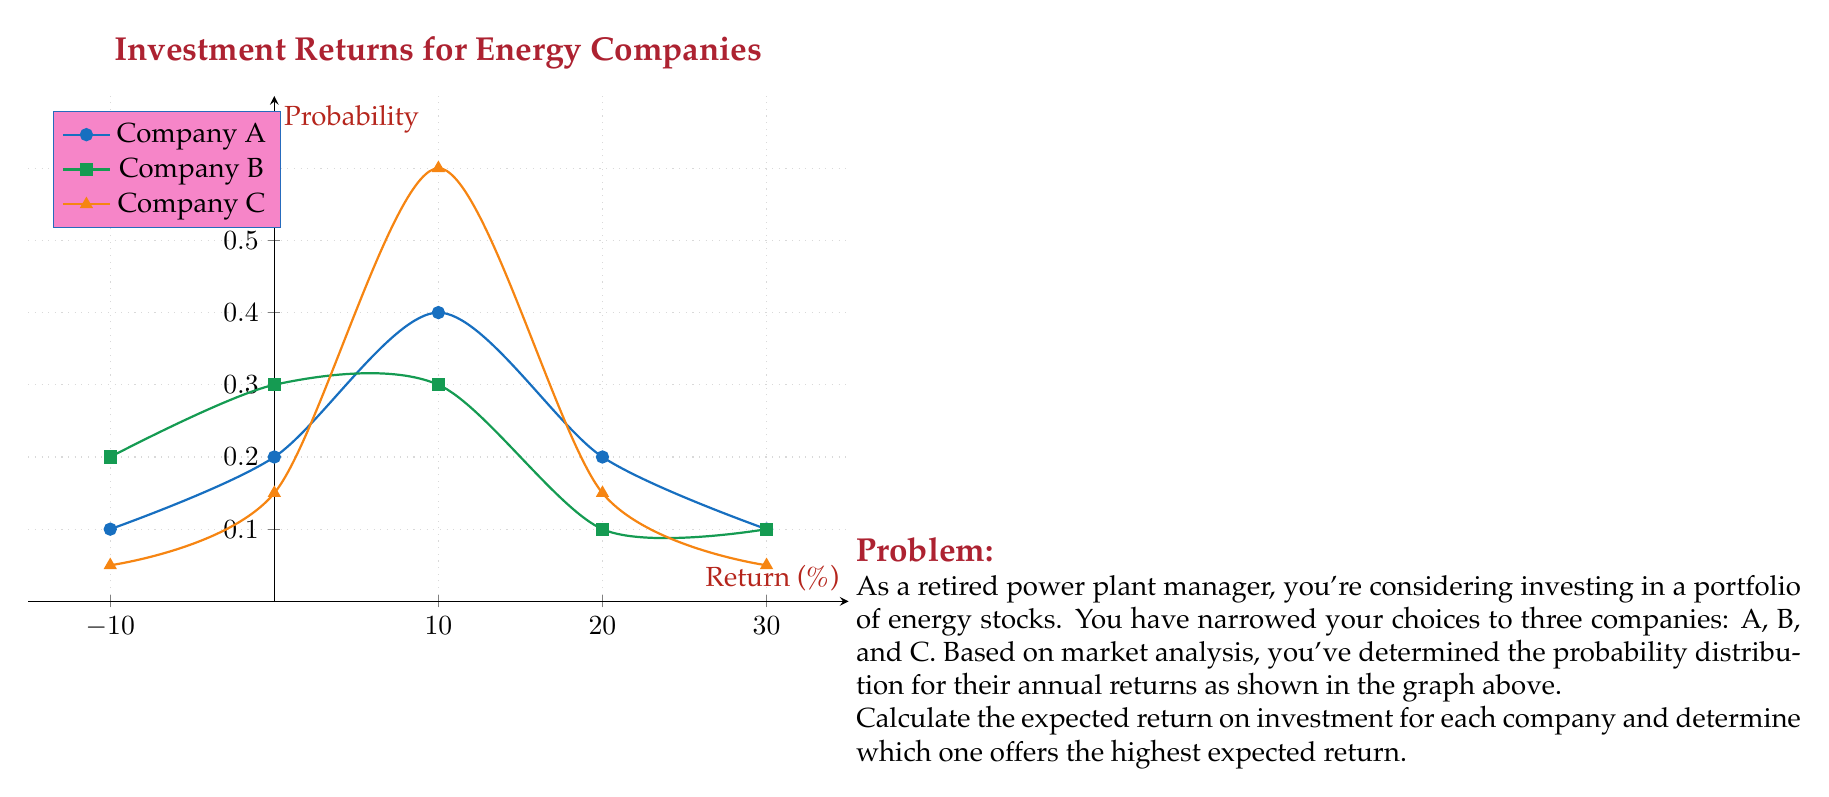Can you solve this math problem? To solve this problem, we need to calculate the expected value of the return for each company using the given probability distributions. The expected value is calculated by multiplying each possible outcome by its probability and summing these products.

For each company, we'll use the formula:

$$E(X) = \sum_{i=1}^{n} x_i \cdot p(x_i)$$

Where $E(X)$ is the expected value, $x_i$ are the possible returns, and $p(x_i)$ are their corresponding probabilities.

Company A:
$$E(A) = (-10 \cdot 0.1) + (0 \cdot 0.2) + (10 \cdot 0.4) + (20 \cdot 0.2) + (30 \cdot 0.1)$$
$$E(A) = -1 + 0 + 4 + 4 + 3 = 10\%$$

Company B:
$$E(B) = (-10 \cdot 0.2) + (0 \cdot 0.3) + (10 \cdot 0.3) + (20 \cdot 0.1) + (30 \cdot 0.1)$$
$$E(B) = -2 + 0 + 3 + 2 + 3 = 6\%$$

Company C:
$$E(C) = (-10 \cdot 0.05) + (0 \cdot 0.15) + (10 \cdot 0.6) + (20 \cdot 0.15) + (30 \cdot 0.05)$$
$$E(C) = -0.5 + 0 + 6 + 3 + 1.5 = 10\%$$

Comparing the expected returns:
Company A: 10%
Company B: 6%
Company C: 10%

Companies A and C both offer the highest expected return of 10%.
Answer: Companies A and C; 10% expected return 